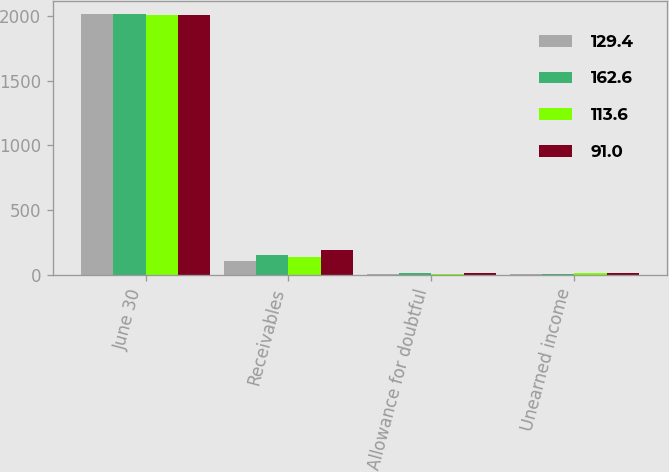Convert chart. <chart><loc_0><loc_0><loc_500><loc_500><stacked_bar_chart><ecel><fcel>June 30<fcel>Receivables<fcel>Allowance for doubtful<fcel>Unearned income<nl><fcel>129.4<fcel>2010<fcel>110.3<fcel>9.4<fcel>9.9<nl><fcel>162.6<fcel>2010<fcel>155<fcel>16.1<fcel>9.5<nl><fcel>113.6<fcel>2009<fcel>136.8<fcel>9.9<fcel>13.3<nl><fcel>91<fcel>2009<fcel>193.4<fcel>18<fcel>12.8<nl></chart> 